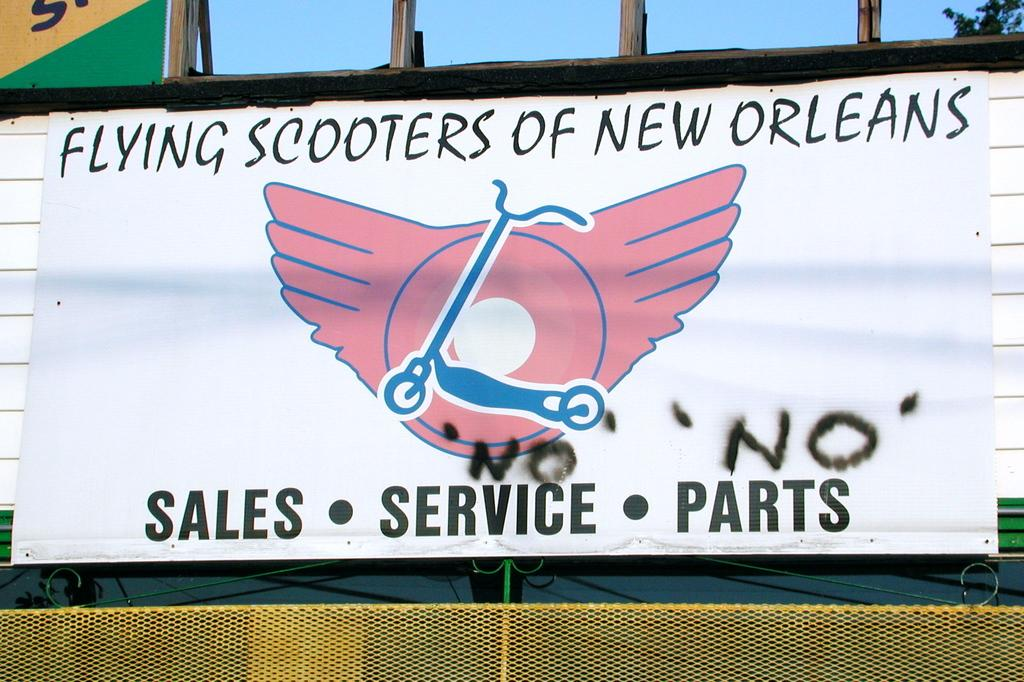<image>
Relay a brief, clear account of the picture shown. The scooter sales store is in New Orleans. 